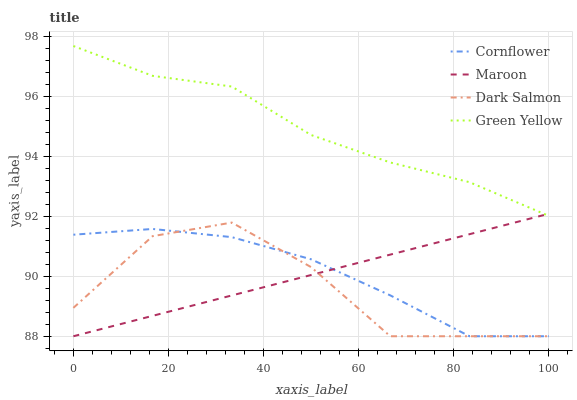Does Dark Salmon have the minimum area under the curve?
Answer yes or no. Yes. Does Green Yellow have the maximum area under the curve?
Answer yes or no. Yes. Does Green Yellow have the minimum area under the curve?
Answer yes or no. No. Does Dark Salmon have the maximum area under the curve?
Answer yes or no. No. Is Maroon the smoothest?
Answer yes or no. Yes. Is Dark Salmon the roughest?
Answer yes or no. Yes. Is Green Yellow the smoothest?
Answer yes or no. No. Is Green Yellow the roughest?
Answer yes or no. No. Does Cornflower have the lowest value?
Answer yes or no. Yes. Does Green Yellow have the lowest value?
Answer yes or no. No. Does Green Yellow have the highest value?
Answer yes or no. Yes. Does Dark Salmon have the highest value?
Answer yes or no. No. Is Cornflower less than Green Yellow?
Answer yes or no. Yes. Is Green Yellow greater than Dark Salmon?
Answer yes or no. Yes. Does Green Yellow intersect Maroon?
Answer yes or no. Yes. Is Green Yellow less than Maroon?
Answer yes or no. No. Is Green Yellow greater than Maroon?
Answer yes or no. No. Does Cornflower intersect Green Yellow?
Answer yes or no. No. 